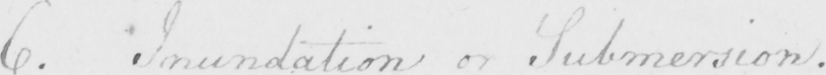Please provide the text content of this handwritten line. 6 . Inundation or Submersion . 